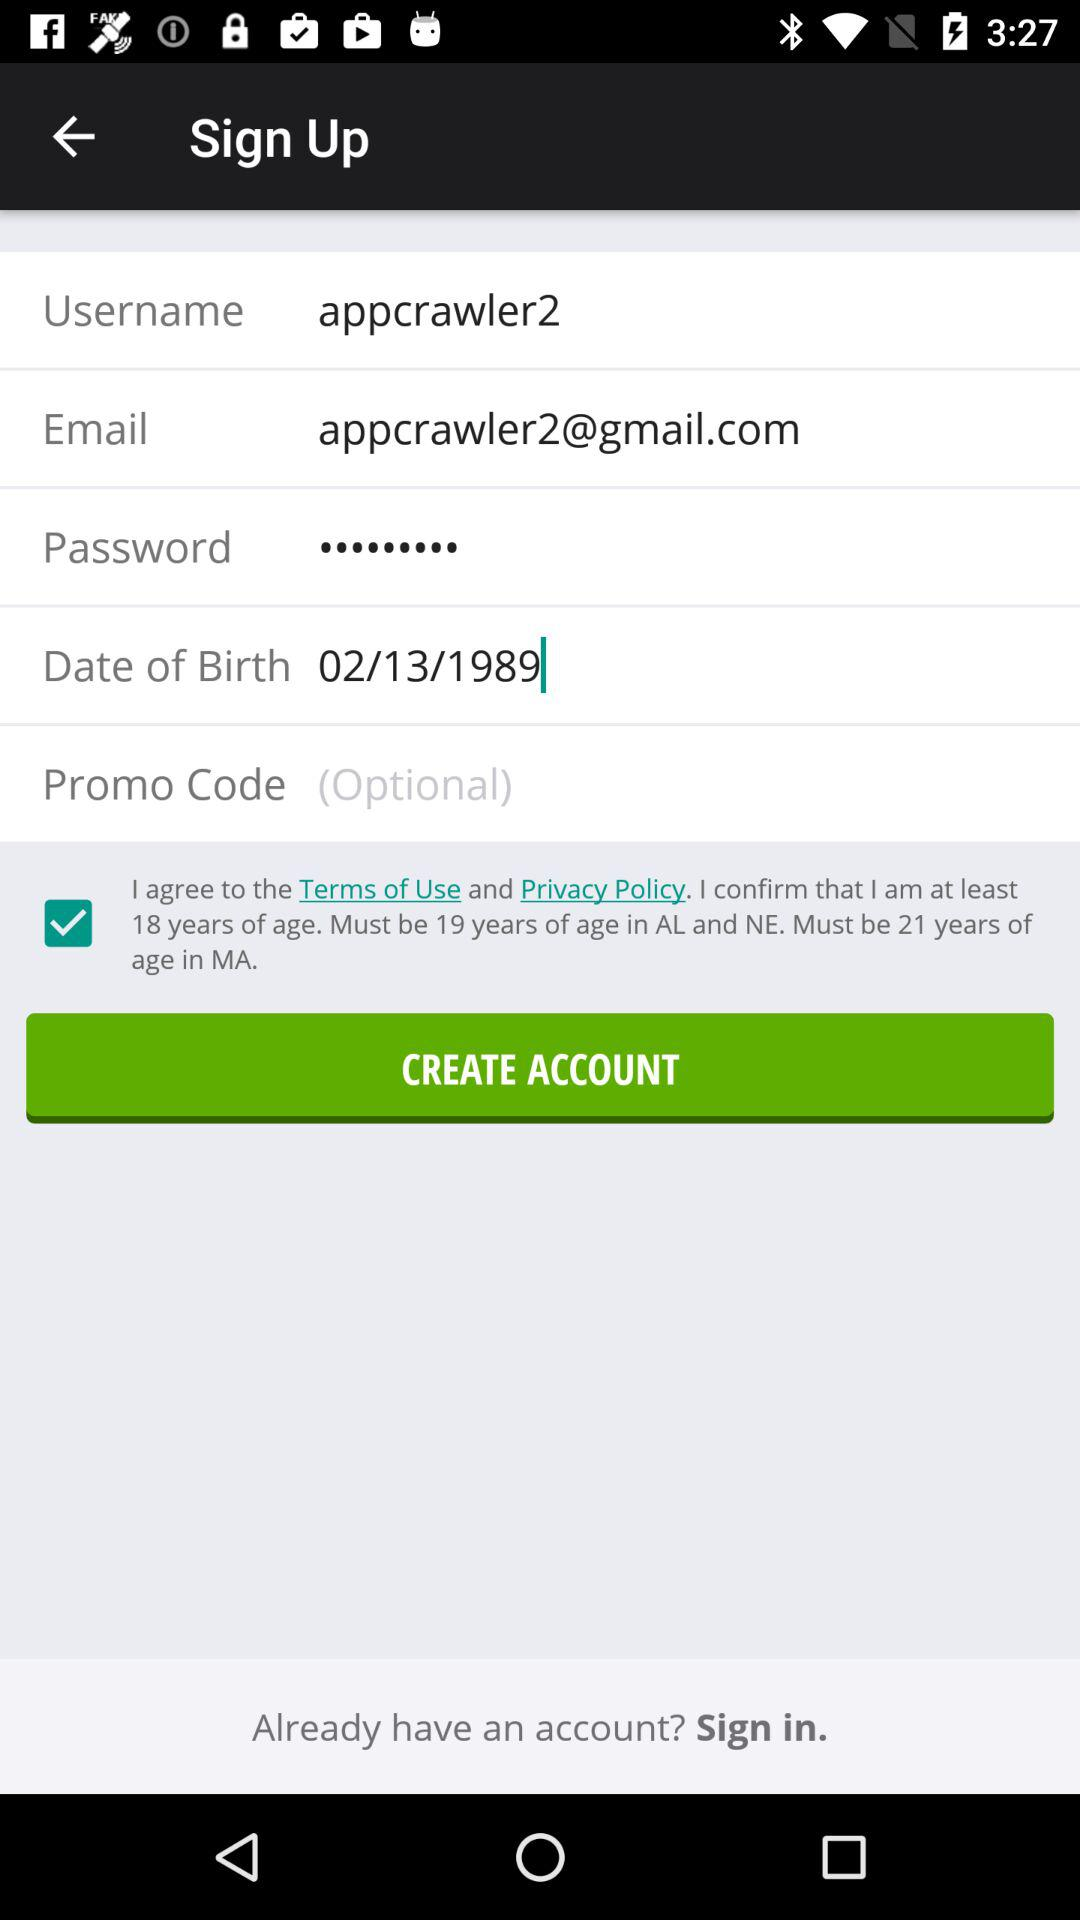What is the mentioned username? The mentioned username is "appcrawler2". 